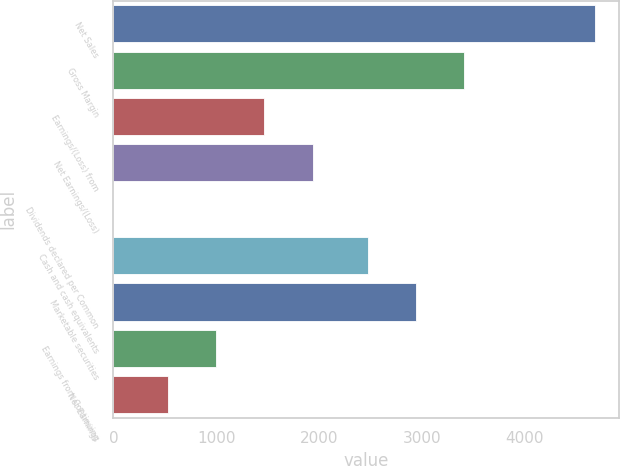Convert chart. <chart><loc_0><loc_0><loc_500><loc_500><bar_chart><fcel>Net Sales<fcel>Gross Margin<fcel>Earnings/(Loss) from<fcel>Net Earnings/(Loss)<fcel>Dividends declared per Common<fcel>Cash and cash equivalents<fcel>Marketable securities<fcel>Earnings from Continuing<fcel>Net Earnings<nl><fcel>4676<fcel>3412.14<fcel>1468.14<fcel>1935.71<fcel>0.28<fcel>2477<fcel>2944.57<fcel>1000.57<fcel>533<nl></chart> 